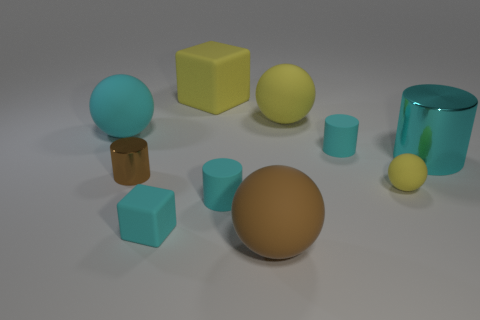What is the color of the metallic cylinder to the right of the matte block that is behind the matte ball that is right of the large yellow rubber sphere?
Make the answer very short. Cyan. Are the tiny sphere and the large cube made of the same material?
Your answer should be compact. Yes. What number of brown things are either small metal cylinders or tiny matte blocks?
Give a very brief answer. 1. What number of big objects are in front of the cyan matte sphere?
Offer a terse response. 2. Is the number of large cyan cylinders greater than the number of green metallic spheres?
Offer a very short reply. Yes. The large matte object that is in front of the small matte cylinder that is behind the tiny brown cylinder is what shape?
Give a very brief answer. Sphere. Is the color of the large metallic cylinder the same as the tiny shiny thing?
Your response must be concise. No. Is the number of big brown rubber things that are left of the small ball greater than the number of large matte cylinders?
Offer a terse response. Yes. What number of big yellow things are to the left of the big cyan thing that is left of the tiny cyan block?
Your answer should be very brief. 0. Are the large cyan sphere behind the small metallic cylinder and the cyan cylinder behind the big cyan cylinder made of the same material?
Provide a short and direct response. Yes. 